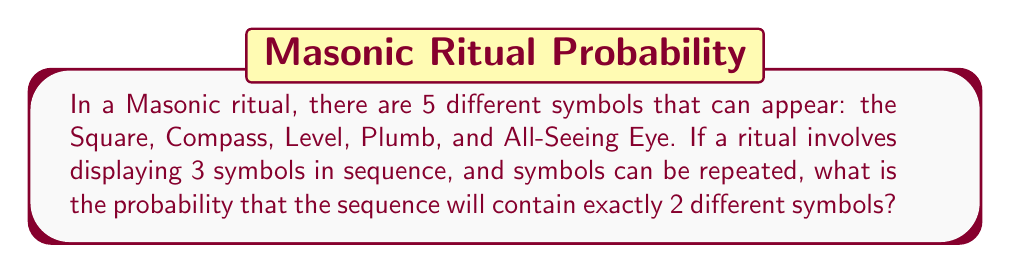Teach me how to tackle this problem. To solve this problem, we need to use the concept of probability and counting principles. Let's break it down step-by-step:

1) First, we need to calculate the total number of possible sequences. With 5 symbols and 3 positions, and allowing repetition, we have:

   Total sequences = $5^3 = 125$

2) Now, we need to count the number of sequences with exactly 2 different symbols. We can do this in two steps:

   a) Choose 2 symbols out of 5: $\binom{5}{2} = 10$ ways

   b) For each of these 10 choices, we need to arrange 3 positions with 2 symbols, where one symbol appears twice and the other once. This can be done in 3 ways:
      - AAB
      - ABA
      - BAA
      where A and B represent the two chosen symbols.

3) So, for each choice of 2 symbols, we have 3 possible arrangements. Therefore, the total number of favorable outcomes is:

   Favorable outcomes = $10 \times 3 = 30$

4) The probability is then:

   $$P(\text{exactly 2 different symbols}) = \frac{\text{Favorable outcomes}}{\text{Total outcomes}} = \frac{30}{125} = \frac{6}{25} = 0.24$$
Answer: The probability of a sequence containing exactly 2 different symbols is $\frac{6}{25}$ or 0.24 or 24%. 